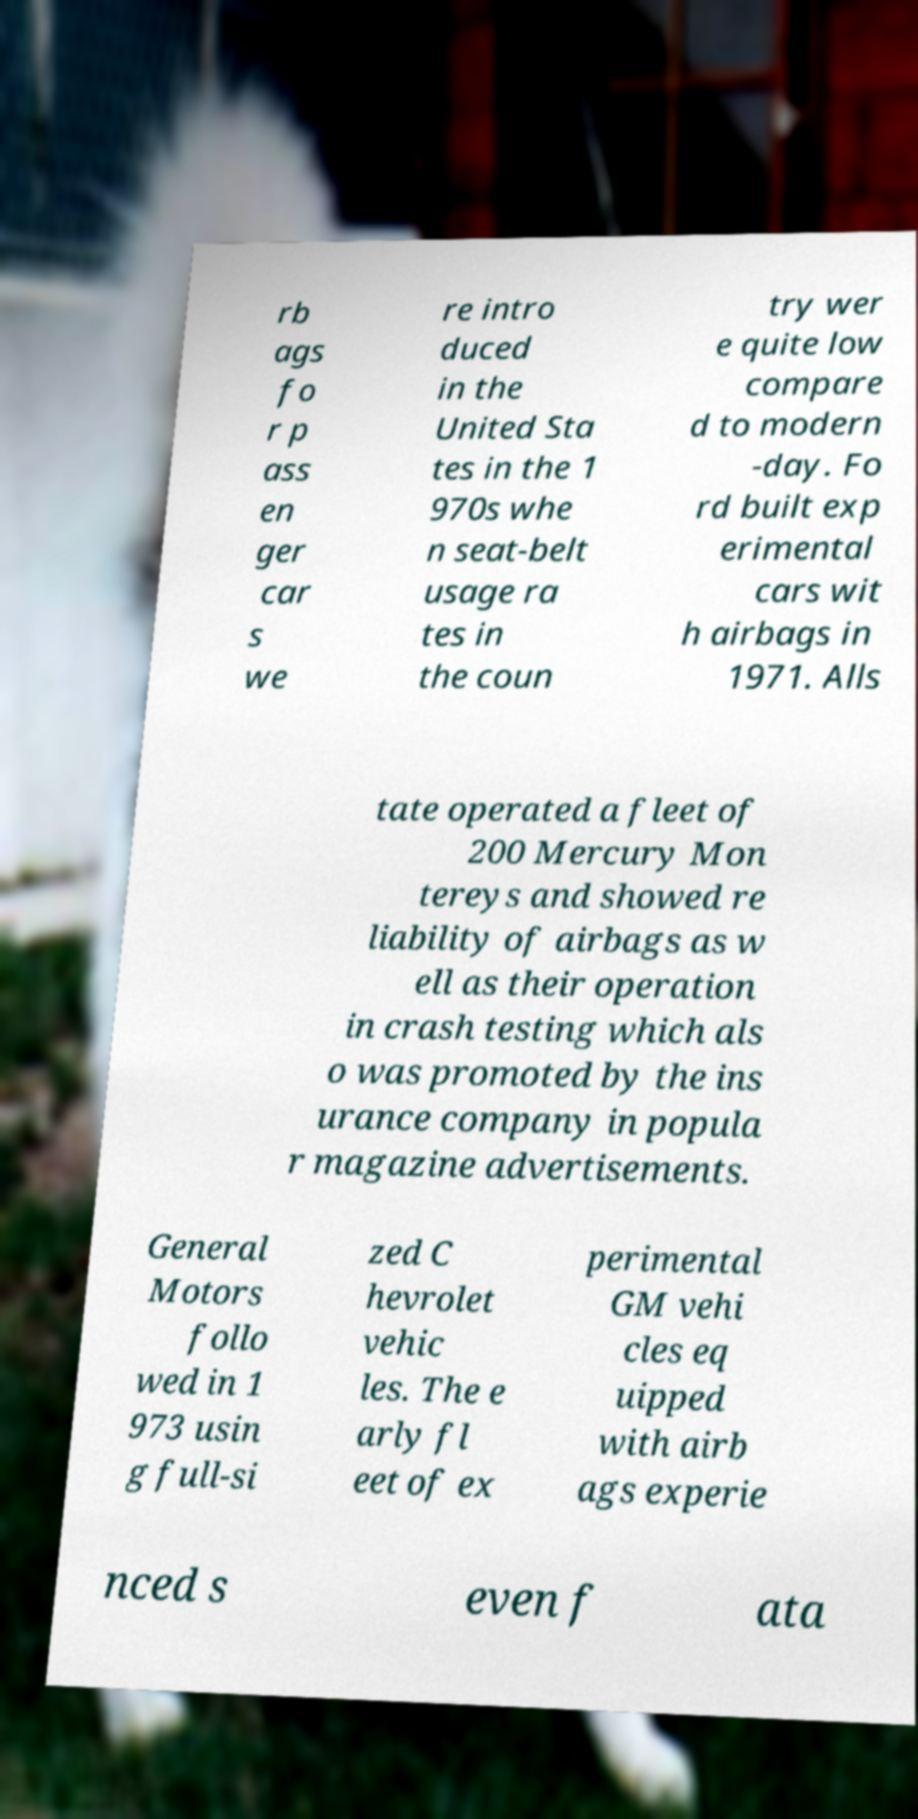For documentation purposes, I need the text within this image transcribed. Could you provide that? rb ags fo r p ass en ger car s we re intro duced in the United Sta tes in the 1 970s whe n seat-belt usage ra tes in the coun try wer e quite low compare d to modern -day. Fo rd built exp erimental cars wit h airbags in 1971. Alls tate operated a fleet of 200 Mercury Mon tereys and showed re liability of airbags as w ell as their operation in crash testing which als o was promoted by the ins urance company in popula r magazine advertisements. General Motors follo wed in 1 973 usin g full-si zed C hevrolet vehic les. The e arly fl eet of ex perimental GM vehi cles eq uipped with airb ags experie nced s even f ata 